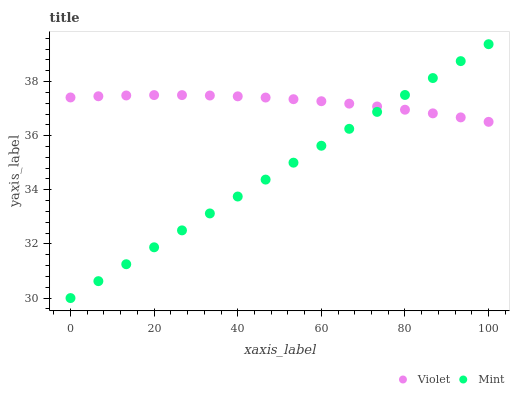Does Mint have the minimum area under the curve?
Answer yes or no. Yes. Does Violet have the maximum area under the curve?
Answer yes or no. Yes. Does Violet have the minimum area under the curve?
Answer yes or no. No. Is Mint the smoothest?
Answer yes or no. Yes. Is Violet the roughest?
Answer yes or no. Yes. Is Violet the smoothest?
Answer yes or no. No. Does Mint have the lowest value?
Answer yes or no. Yes. Does Violet have the lowest value?
Answer yes or no. No. Does Mint have the highest value?
Answer yes or no. Yes. Does Violet have the highest value?
Answer yes or no. No. Does Mint intersect Violet?
Answer yes or no. Yes. Is Mint less than Violet?
Answer yes or no. No. Is Mint greater than Violet?
Answer yes or no. No. 